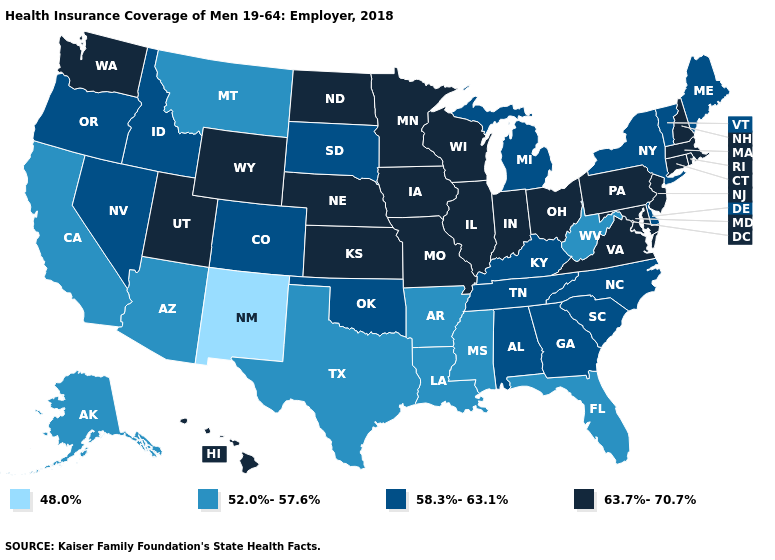Among the states that border Montana , which have the lowest value?
Quick response, please. Idaho, South Dakota. Is the legend a continuous bar?
Keep it brief. No. What is the value of Connecticut?
Concise answer only. 63.7%-70.7%. Name the states that have a value in the range 58.3%-63.1%?
Answer briefly. Alabama, Colorado, Delaware, Georgia, Idaho, Kentucky, Maine, Michigan, Nevada, New York, North Carolina, Oklahoma, Oregon, South Carolina, South Dakota, Tennessee, Vermont. Name the states that have a value in the range 48.0%?
Be succinct. New Mexico. Name the states that have a value in the range 52.0%-57.6%?
Give a very brief answer. Alaska, Arizona, Arkansas, California, Florida, Louisiana, Mississippi, Montana, Texas, West Virginia. Does the map have missing data?
Keep it brief. No. Name the states that have a value in the range 58.3%-63.1%?
Short answer required. Alabama, Colorado, Delaware, Georgia, Idaho, Kentucky, Maine, Michigan, Nevada, New York, North Carolina, Oklahoma, Oregon, South Carolina, South Dakota, Tennessee, Vermont. Name the states that have a value in the range 58.3%-63.1%?
Keep it brief. Alabama, Colorado, Delaware, Georgia, Idaho, Kentucky, Maine, Michigan, Nevada, New York, North Carolina, Oklahoma, Oregon, South Carolina, South Dakota, Tennessee, Vermont. Does the first symbol in the legend represent the smallest category?
Be succinct. Yes. Among the states that border Ohio , which have the lowest value?
Short answer required. West Virginia. Does Arkansas have the lowest value in the South?
Quick response, please. Yes. What is the value of Maryland?
Answer briefly. 63.7%-70.7%. Does Maryland have a higher value than Minnesota?
Short answer required. No. What is the value of Alabama?
Answer briefly. 58.3%-63.1%. 